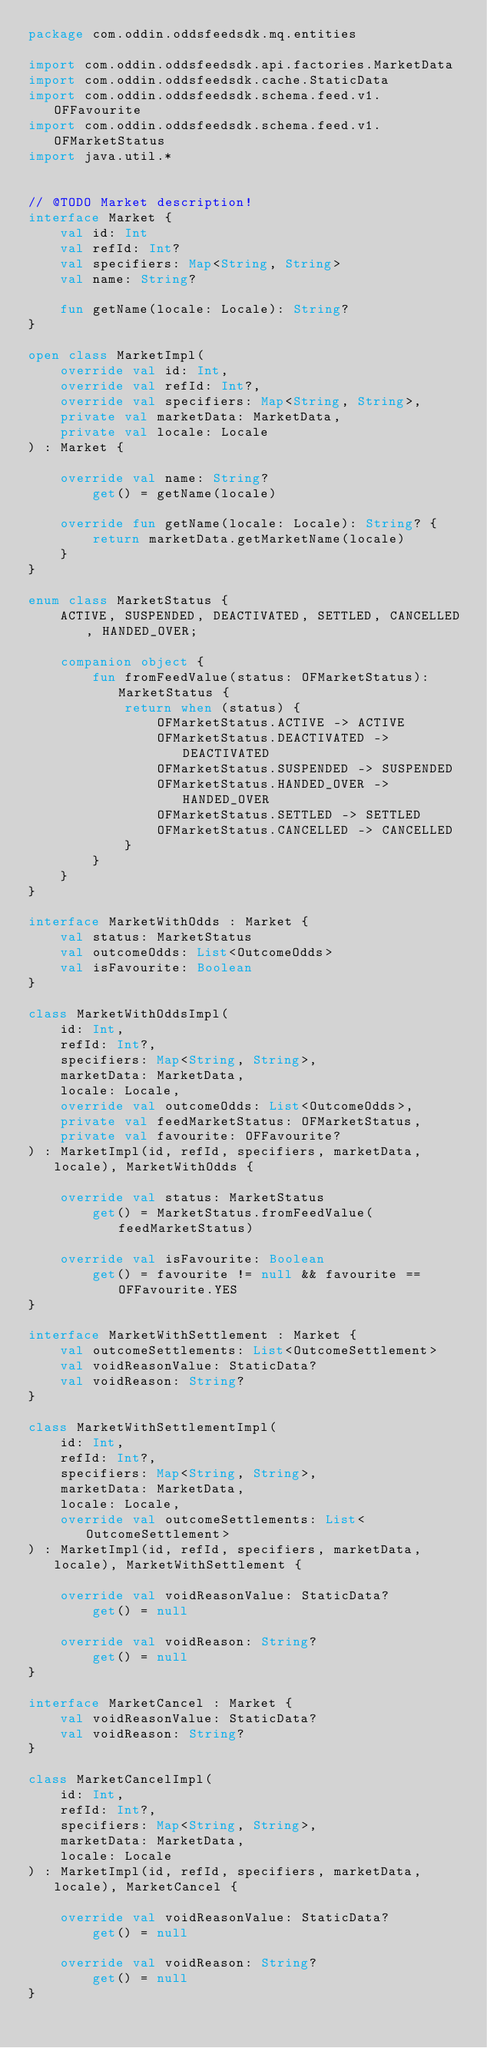<code> <loc_0><loc_0><loc_500><loc_500><_Kotlin_>package com.oddin.oddsfeedsdk.mq.entities

import com.oddin.oddsfeedsdk.api.factories.MarketData
import com.oddin.oddsfeedsdk.cache.StaticData
import com.oddin.oddsfeedsdk.schema.feed.v1.OFFavourite
import com.oddin.oddsfeedsdk.schema.feed.v1.OFMarketStatus
import java.util.*


// @TODO Market description!
interface Market {
    val id: Int
    val refId: Int?
    val specifiers: Map<String, String>
    val name: String?

    fun getName(locale: Locale): String?
}

open class MarketImpl(
    override val id: Int,
    override val refId: Int?,
    override val specifiers: Map<String, String>,
    private val marketData: MarketData,
    private val locale: Locale
) : Market {

    override val name: String?
        get() = getName(locale)

    override fun getName(locale: Locale): String? {
        return marketData.getMarketName(locale)
    }
}

enum class MarketStatus {
    ACTIVE, SUSPENDED, DEACTIVATED, SETTLED, CANCELLED, HANDED_OVER;

    companion object {
        fun fromFeedValue(status: OFMarketStatus): MarketStatus {
            return when (status) {
                OFMarketStatus.ACTIVE -> ACTIVE
                OFMarketStatus.DEACTIVATED -> DEACTIVATED
                OFMarketStatus.SUSPENDED -> SUSPENDED
                OFMarketStatus.HANDED_OVER -> HANDED_OVER
                OFMarketStatus.SETTLED -> SETTLED
                OFMarketStatus.CANCELLED -> CANCELLED
            }
        }
    }
}

interface MarketWithOdds : Market {
    val status: MarketStatus
    val outcomeOdds: List<OutcomeOdds>
    val isFavourite: Boolean
}

class MarketWithOddsImpl(
    id: Int,
    refId: Int?,
    specifiers: Map<String, String>,
    marketData: MarketData,
    locale: Locale,
    override val outcomeOdds: List<OutcomeOdds>,
    private val feedMarketStatus: OFMarketStatus,
    private val favourite: OFFavourite?
) : MarketImpl(id, refId, specifiers, marketData, locale), MarketWithOdds {

    override val status: MarketStatus
        get() = MarketStatus.fromFeedValue(feedMarketStatus)

    override val isFavourite: Boolean
        get() = favourite != null && favourite == OFFavourite.YES
}

interface MarketWithSettlement : Market {
    val outcomeSettlements: List<OutcomeSettlement>
    val voidReasonValue: StaticData?
    val voidReason: String?
}

class MarketWithSettlementImpl(
    id: Int,
    refId: Int?,
    specifiers: Map<String, String>,
    marketData: MarketData,
    locale: Locale,
    override val outcomeSettlements: List<OutcomeSettlement>
) : MarketImpl(id, refId, specifiers, marketData, locale), MarketWithSettlement {

    override val voidReasonValue: StaticData?
        get() = null

    override val voidReason: String?
        get() = null
}

interface MarketCancel : Market {
    val voidReasonValue: StaticData?
    val voidReason: String?
}

class MarketCancelImpl(
    id: Int,
    refId: Int?,
    specifiers: Map<String, String>,
    marketData: MarketData,
    locale: Locale
) : MarketImpl(id, refId, specifiers, marketData, locale), MarketCancel {

    override val voidReasonValue: StaticData?
        get() = null

    override val voidReason: String?
        get() = null
}</code> 